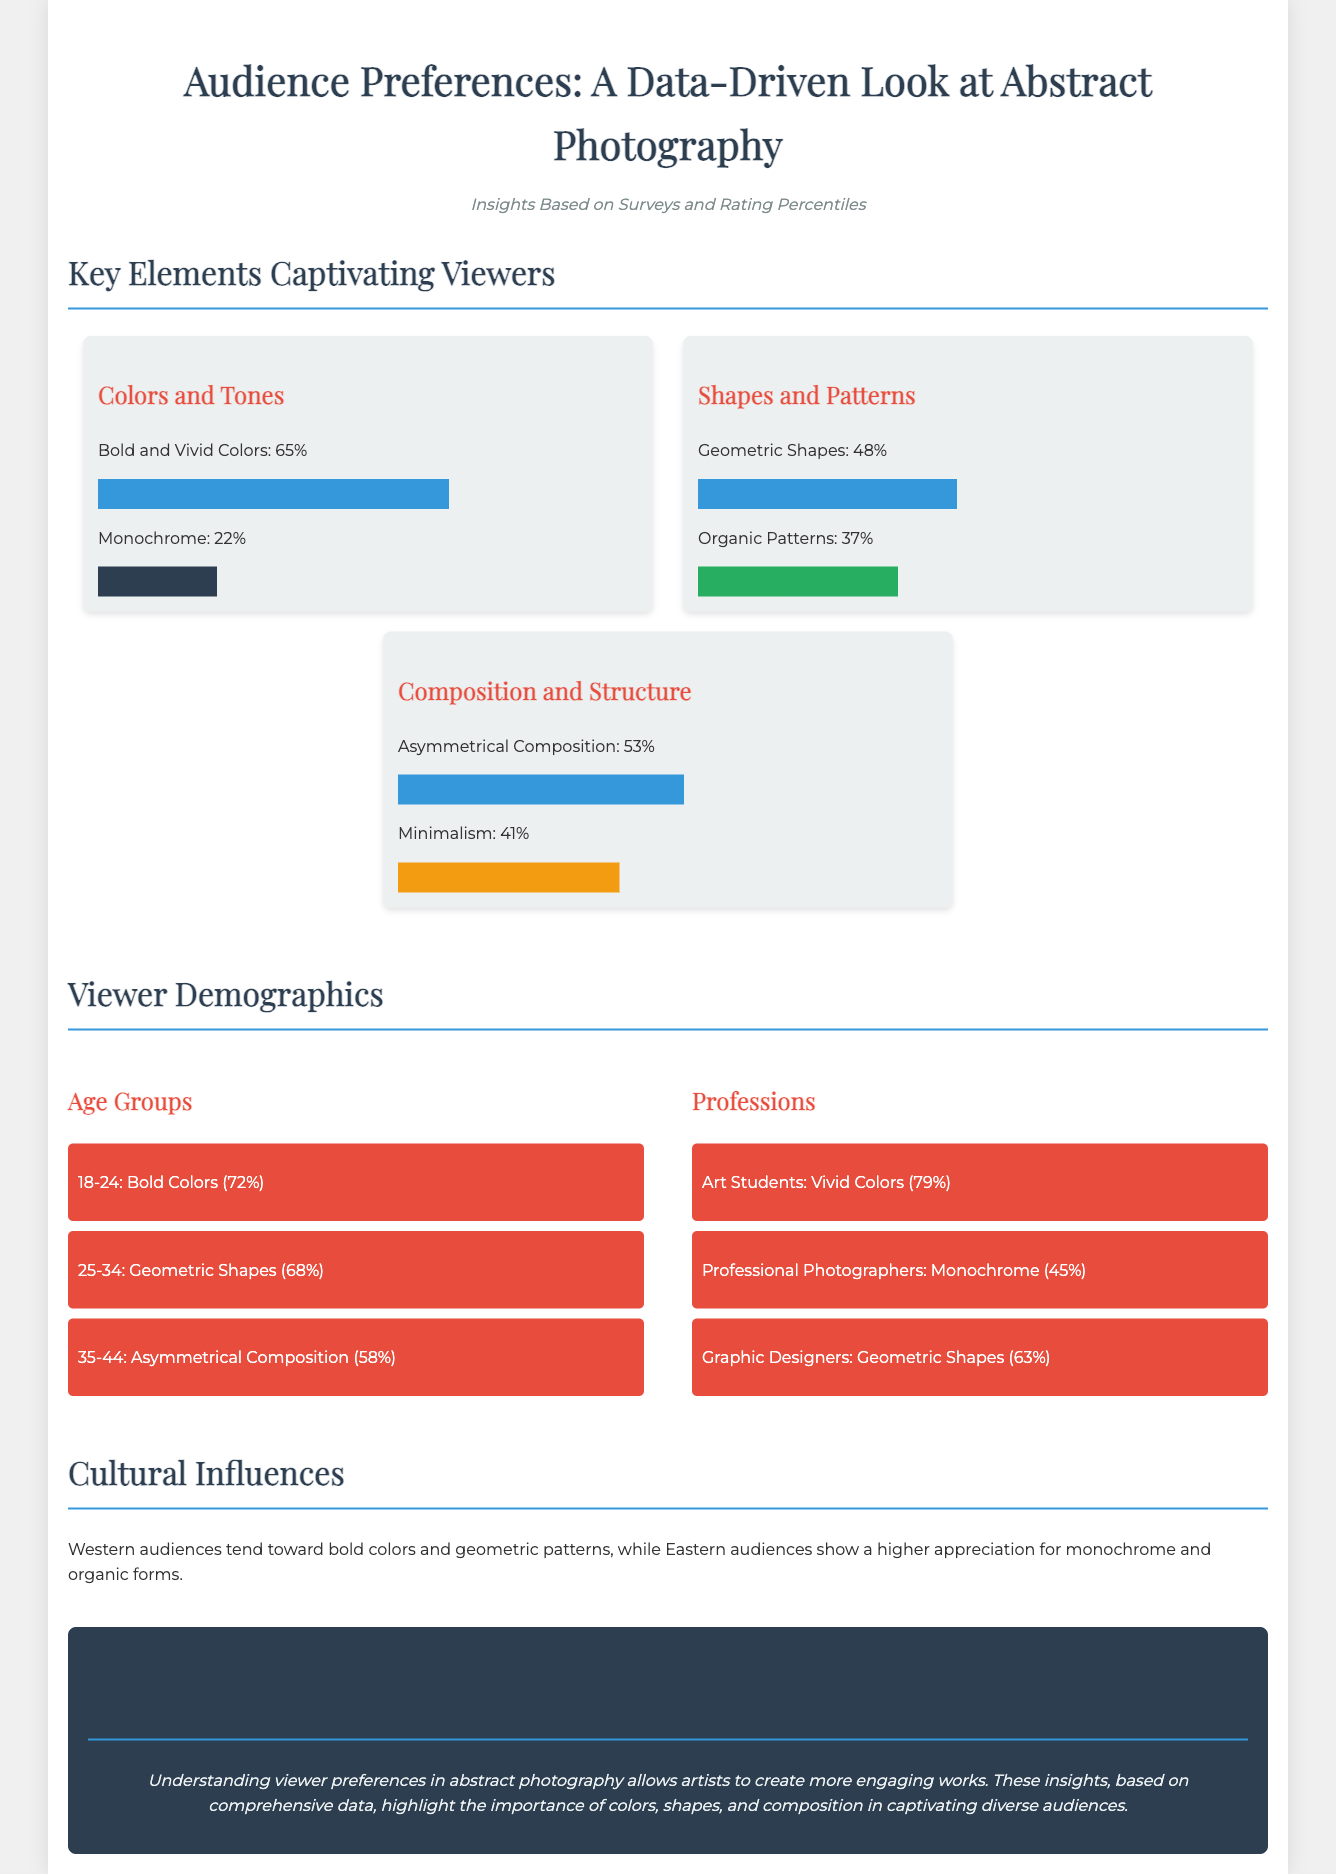what percentage of viewers prefer bold and vivid colors in abstract photography? The document states that 65% of viewers prefer bold and vivid colors in abstract photography.
Answer: 65% which age group shows a preference for geometric shapes? The document indicates that the 25-34 age group shows a preference for geometric shapes at 68%.
Answer: 25-34 what composition style is preferred by 53% of viewers? The document mentions that 53% of viewers prefer asymmetrical composition in abstract photography.
Answer: Asymmetrical Composition what percentage of art students prefer vivid colors? According to the document, 79% of art students prefer vivid colors in abstract photography.
Answer: 79% which cultural influence emphasizes organic forms more? The document suggests that Eastern audiences show a higher appreciation for organic forms.
Answer: Eastern audiences how many percentages represent monochrome preferences among professional photographers? The document states that 45% of professional photographers prefer monochrome in their abstract photography choices.
Answer: 45% which group has the least preference for monochrome? The document indicates that art students have the least preference for monochrome, with no specific percentage listed.
Answer: Art Students what is the main theme of the conclusion section? The conclusion emphasizes understanding viewer preferences to create more engaging abstract photography.
Answer: Engaging Works what do Western audiences tend to prefer in abstract photography? The document states that Western audiences tend toward bold colors and geometric patterns.
Answer: Bold colors and geometric patterns 